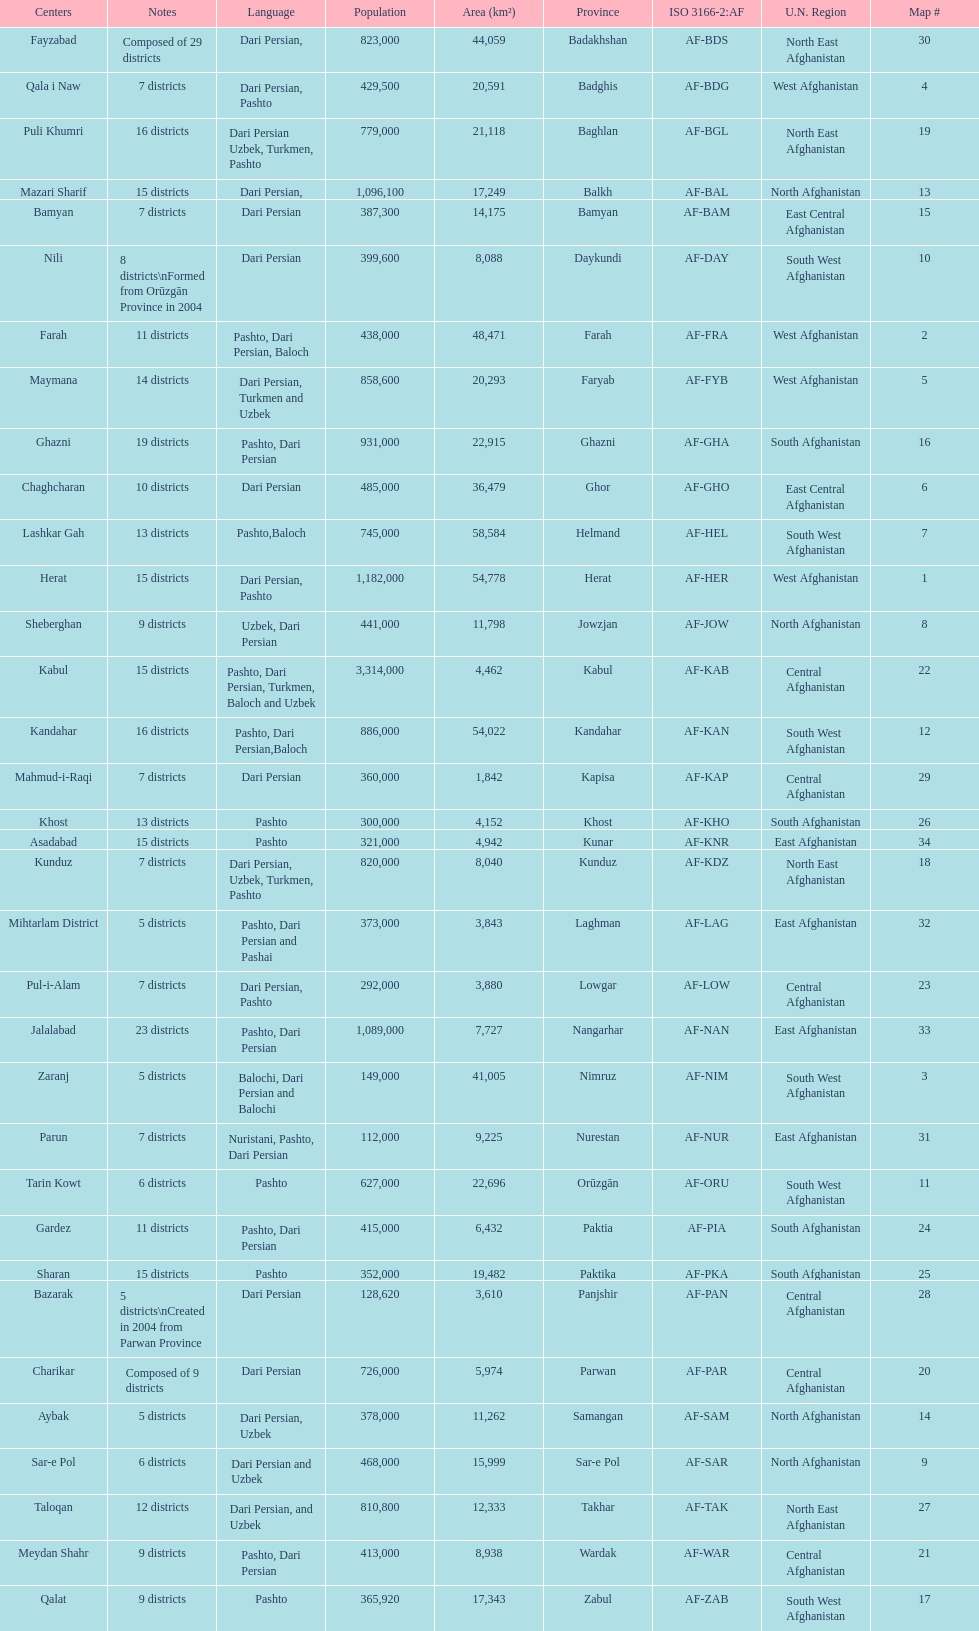How many districts are in the province of kunduz? 7. 